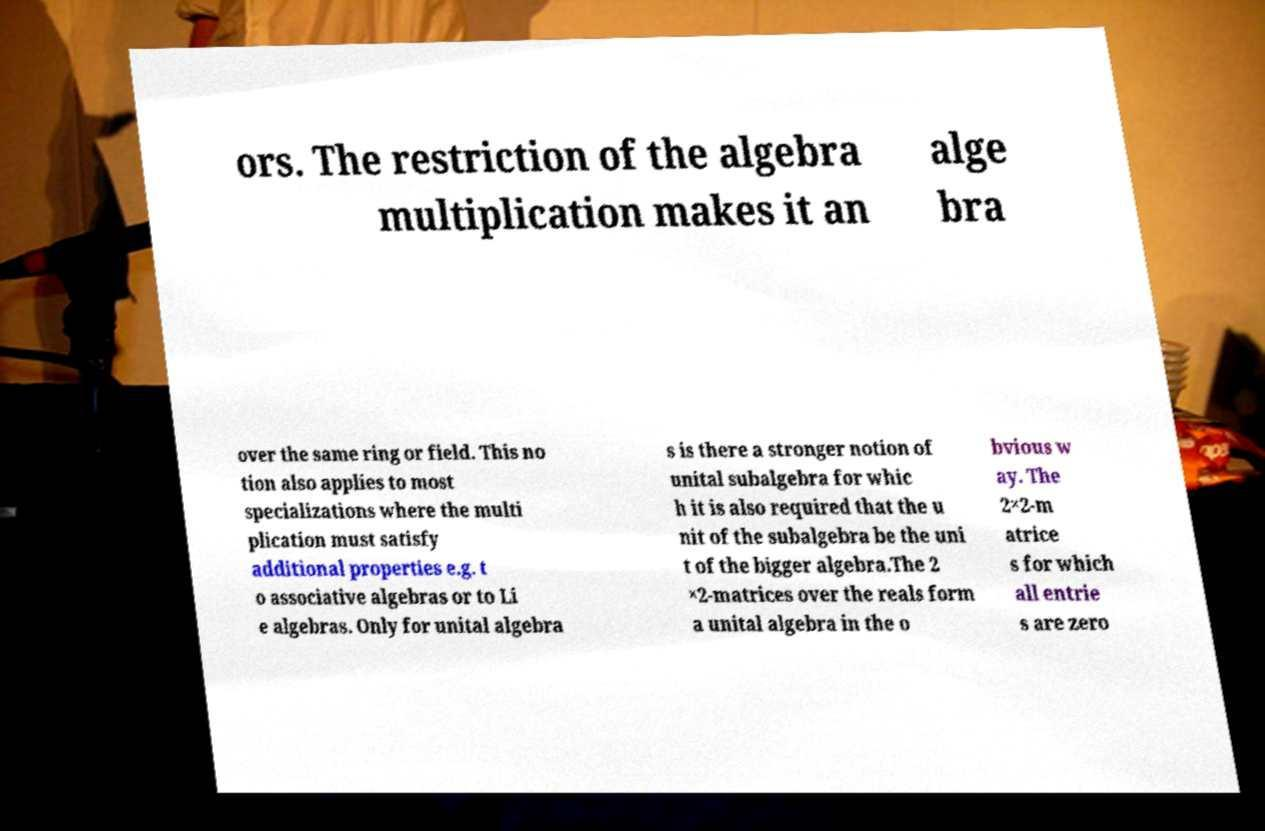Please identify and transcribe the text found in this image. ors. The restriction of the algebra multiplication makes it an alge bra over the same ring or field. This no tion also applies to most specializations where the multi plication must satisfy additional properties e.g. t o associative algebras or to Li e algebras. Only for unital algebra s is there a stronger notion of unital subalgebra for whic h it is also required that the u nit of the subalgebra be the uni t of the bigger algebra.The 2 ×2-matrices over the reals form a unital algebra in the o bvious w ay. The 2×2-m atrice s for which all entrie s are zero 